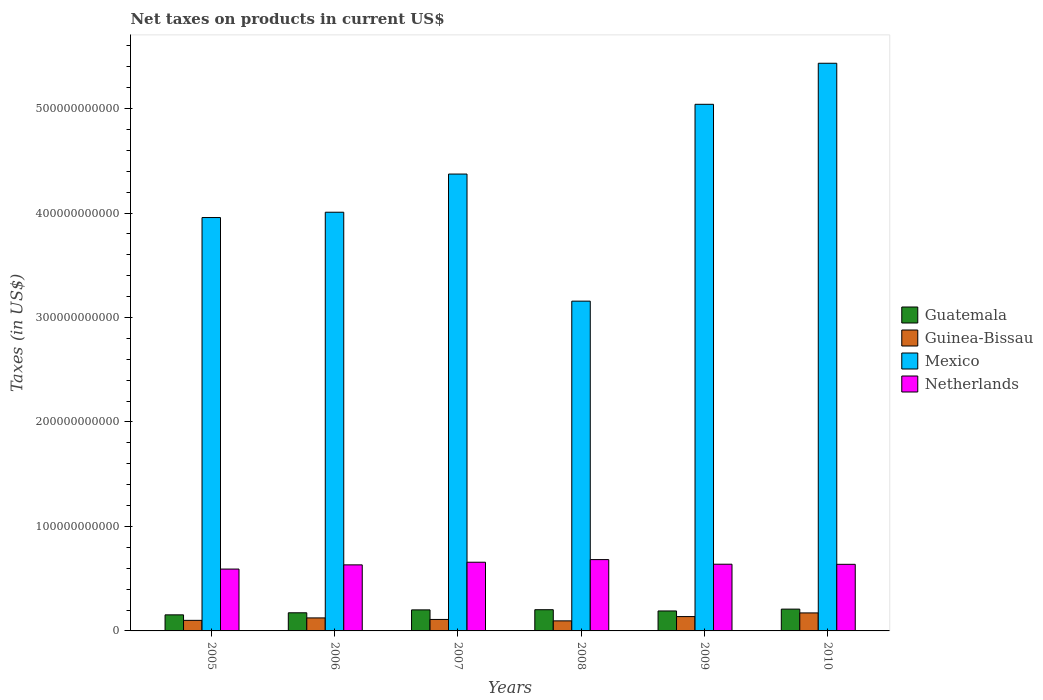How many groups of bars are there?
Give a very brief answer. 6. Are the number of bars per tick equal to the number of legend labels?
Your response must be concise. Yes. Are the number of bars on each tick of the X-axis equal?
Offer a very short reply. Yes. What is the label of the 5th group of bars from the left?
Your answer should be very brief. 2009. What is the net taxes on products in Guinea-Bissau in 2008?
Give a very brief answer. 9.62e+09. Across all years, what is the maximum net taxes on products in Guatemala?
Keep it short and to the point. 2.09e+1. Across all years, what is the minimum net taxes on products in Guinea-Bissau?
Your response must be concise. 9.62e+09. What is the total net taxes on products in Guinea-Bissau in the graph?
Give a very brief answer. 7.41e+1. What is the difference between the net taxes on products in Guatemala in 2006 and that in 2007?
Your response must be concise. -2.77e+09. What is the difference between the net taxes on products in Mexico in 2010 and the net taxes on products in Netherlands in 2009?
Give a very brief answer. 4.80e+11. What is the average net taxes on products in Guatemala per year?
Provide a short and direct response. 1.89e+1. In the year 2009, what is the difference between the net taxes on products in Guinea-Bissau and net taxes on products in Netherlands?
Your response must be concise. -5.01e+1. What is the ratio of the net taxes on products in Guatemala in 2009 to that in 2010?
Ensure brevity in your answer.  0.92. Is the difference between the net taxes on products in Guinea-Bissau in 2005 and 2009 greater than the difference between the net taxes on products in Netherlands in 2005 and 2009?
Your response must be concise. Yes. What is the difference between the highest and the second highest net taxes on products in Guinea-Bissau?
Give a very brief answer. 3.51e+09. What is the difference between the highest and the lowest net taxes on products in Netherlands?
Offer a terse response. 9.07e+09. Is the sum of the net taxes on products in Mexico in 2005 and 2006 greater than the maximum net taxes on products in Guatemala across all years?
Ensure brevity in your answer.  Yes. Is it the case that in every year, the sum of the net taxes on products in Guatemala and net taxes on products in Guinea-Bissau is greater than the sum of net taxes on products in Mexico and net taxes on products in Netherlands?
Keep it short and to the point. No. What does the 1st bar from the left in 2008 represents?
Offer a very short reply. Guatemala. What does the 3rd bar from the right in 2006 represents?
Ensure brevity in your answer.  Guinea-Bissau. Is it the case that in every year, the sum of the net taxes on products in Guatemala and net taxes on products in Guinea-Bissau is greater than the net taxes on products in Netherlands?
Ensure brevity in your answer.  No. Are all the bars in the graph horizontal?
Offer a very short reply. No. How many years are there in the graph?
Give a very brief answer. 6. What is the difference between two consecutive major ticks on the Y-axis?
Your response must be concise. 1.00e+11. Does the graph contain any zero values?
Offer a terse response. No. How are the legend labels stacked?
Your answer should be very brief. Vertical. What is the title of the graph?
Offer a very short reply. Net taxes on products in current US$. What is the label or title of the Y-axis?
Provide a short and direct response. Taxes (in US$). What is the Taxes (in US$) in Guatemala in 2005?
Provide a succinct answer. 1.54e+1. What is the Taxes (in US$) in Guinea-Bissau in 2005?
Provide a short and direct response. 1.01e+1. What is the Taxes (in US$) in Mexico in 2005?
Give a very brief answer. 3.96e+11. What is the Taxes (in US$) of Netherlands in 2005?
Make the answer very short. 5.92e+1. What is the Taxes (in US$) of Guatemala in 2006?
Your answer should be compact. 1.74e+1. What is the Taxes (in US$) of Guinea-Bissau in 2006?
Provide a short and direct response. 1.25e+1. What is the Taxes (in US$) of Mexico in 2006?
Offer a very short reply. 4.01e+11. What is the Taxes (in US$) in Netherlands in 2006?
Your answer should be very brief. 6.32e+1. What is the Taxes (in US$) in Guatemala in 2007?
Make the answer very short. 2.01e+1. What is the Taxes (in US$) of Guinea-Bissau in 2007?
Ensure brevity in your answer.  1.10e+1. What is the Taxes (in US$) of Mexico in 2007?
Your answer should be compact. 4.37e+11. What is the Taxes (in US$) in Netherlands in 2007?
Make the answer very short. 6.58e+1. What is the Taxes (in US$) in Guatemala in 2008?
Your answer should be very brief. 2.03e+1. What is the Taxes (in US$) in Guinea-Bissau in 2008?
Your answer should be compact. 9.62e+09. What is the Taxes (in US$) of Mexico in 2008?
Make the answer very short. 3.16e+11. What is the Taxes (in US$) in Netherlands in 2008?
Ensure brevity in your answer.  6.83e+1. What is the Taxes (in US$) of Guatemala in 2009?
Your answer should be very brief. 1.91e+1. What is the Taxes (in US$) in Guinea-Bissau in 2009?
Ensure brevity in your answer.  1.37e+1. What is the Taxes (in US$) of Mexico in 2009?
Make the answer very short. 5.04e+11. What is the Taxes (in US$) of Netherlands in 2009?
Ensure brevity in your answer.  6.39e+1. What is the Taxes (in US$) in Guatemala in 2010?
Your answer should be compact. 2.09e+1. What is the Taxes (in US$) in Guinea-Bissau in 2010?
Offer a very short reply. 1.72e+1. What is the Taxes (in US$) in Mexico in 2010?
Your answer should be very brief. 5.43e+11. What is the Taxes (in US$) in Netherlands in 2010?
Give a very brief answer. 6.38e+1. Across all years, what is the maximum Taxes (in US$) in Guatemala?
Offer a terse response. 2.09e+1. Across all years, what is the maximum Taxes (in US$) of Guinea-Bissau?
Keep it short and to the point. 1.72e+1. Across all years, what is the maximum Taxes (in US$) of Mexico?
Your response must be concise. 5.43e+11. Across all years, what is the maximum Taxes (in US$) of Netherlands?
Keep it short and to the point. 6.83e+1. Across all years, what is the minimum Taxes (in US$) in Guatemala?
Give a very brief answer. 1.54e+1. Across all years, what is the minimum Taxes (in US$) of Guinea-Bissau?
Provide a succinct answer. 9.62e+09. Across all years, what is the minimum Taxes (in US$) in Mexico?
Ensure brevity in your answer.  3.16e+11. Across all years, what is the minimum Taxes (in US$) of Netherlands?
Keep it short and to the point. 5.92e+1. What is the total Taxes (in US$) in Guatemala in the graph?
Keep it short and to the point. 1.13e+11. What is the total Taxes (in US$) of Guinea-Bissau in the graph?
Provide a short and direct response. 7.41e+1. What is the total Taxes (in US$) in Mexico in the graph?
Offer a terse response. 2.60e+12. What is the total Taxes (in US$) in Netherlands in the graph?
Your response must be concise. 3.84e+11. What is the difference between the Taxes (in US$) in Guatemala in 2005 and that in 2006?
Your answer should be compact. -1.97e+09. What is the difference between the Taxes (in US$) of Guinea-Bissau in 2005 and that in 2006?
Your answer should be very brief. -2.34e+09. What is the difference between the Taxes (in US$) in Mexico in 2005 and that in 2006?
Provide a short and direct response. -5.09e+09. What is the difference between the Taxes (in US$) of Netherlands in 2005 and that in 2006?
Offer a terse response. -4.02e+09. What is the difference between the Taxes (in US$) of Guatemala in 2005 and that in 2007?
Offer a terse response. -4.75e+09. What is the difference between the Taxes (in US$) of Guinea-Bissau in 2005 and that in 2007?
Provide a succinct answer. -8.67e+08. What is the difference between the Taxes (in US$) in Mexico in 2005 and that in 2007?
Ensure brevity in your answer.  -4.16e+1. What is the difference between the Taxes (in US$) of Netherlands in 2005 and that in 2007?
Provide a succinct answer. -6.56e+09. What is the difference between the Taxes (in US$) of Guatemala in 2005 and that in 2008?
Your answer should be very brief. -4.92e+09. What is the difference between the Taxes (in US$) in Guinea-Bissau in 2005 and that in 2008?
Keep it short and to the point. 4.96e+08. What is the difference between the Taxes (in US$) in Mexico in 2005 and that in 2008?
Ensure brevity in your answer.  8.00e+1. What is the difference between the Taxes (in US$) in Netherlands in 2005 and that in 2008?
Keep it short and to the point. -9.07e+09. What is the difference between the Taxes (in US$) of Guatemala in 2005 and that in 2009?
Your response must be concise. -3.72e+09. What is the difference between the Taxes (in US$) of Guinea-Bissau in 2005 and that in 2009?
Ensure brevity in your answer.  -3.60e+09. What is the difference between the Taxes (in US$) in Mexico in 2005 and that in 2009?
Give a very brief answer. -1.08e+11. What is the difference between the Taxes (in US$) in Netherlands in 2005 and that in 2009?
Your answer should be very brief. -4.64e+09. What is the difference between the Taxes (in US$) in Guatemala in 2005 and that in 2010?
Make the answer very short. -5.48e+09. What is the difference between the Taxes (in US$) of Guinea-Bissau in 2005 and that in 2010?
Your response must be concise. -7.11e+09. What is the difference between the Taxes (in US$) of Mexico in 2005 and that in 2010?
Make the answer very short. -1.48e+11. What is the difference between the Taxes (in US$) in Netherlands in 2005 and that in 2010?
Your answer should be compact. -4.55e+09. What is the difference between the Taxes (in US$) of Guatemala in 2006 and that in 2007?
Keep it short and to the point. -2.77e+09. What is the difference between the Taxes (in US$) of Guinea-Bissau in 2006 and that in 2007?
Ensure brevity in your answer.  1.47e+09. What is the difference between the Taxes (in US$) in Mexico in 2006 and that in 2007?
Your answer should be very brief. -3.65e+1. What is the difference between the Taxes (in US$) in Netherlands in 2006 and that in 2007?
Keep it short and to the point. -2.54e+09. What is the difference between the Taxes (in US$) in Guatemala in 2006 and that in 2008?
Your response must be concise. -2.95e+09. What is the difference between the Taxes (in US$) in Guinea-Bissau in 2006 and that in 2008?
Keep it short and to the point. 2.83e+09. What is the difference between the Taxes (in US$) of Mexico in 2006 and that in 2008?
Make the answer very short. 8.51e+1. What is the difference between the Taxes (in US$) of Netherlands in 2006 and that in 2008?
Offer a very short reply. -5.05e+09. What is the difference between the Taxes (in US$) of Guatemala in 2006 and that in 2009?
Make the answer very short. -1.74e+09. What is the difference between the Taxes (in US$) of Guinea-Bissau in 2006 and that in 2009?
Make the answer very short. -1.27e+09. What is the difference between the Taxes (in US$) in Mexico in 2006 and that in 2009?
Make the answer very short. -1.03e+11. What is the difference between the Taxes (in US$) in Netherlands in 2006 and that in 2009?
Ensure brevity in your answer.  -6.25e+08. What is the difference between the Taxes (in US$) of Guatemala in 2006 and that in 2010?
Provide a succinct answer. -3.51e+09. What is the difference between the Taxes (in US$) in Guinea-Bissau in 2006 and that in 2010?
Provide a succinct answer. -4.78e+09. What is the difference between the Taxes (in US$) in Mexico in 2006 and that in 2010?
Your answer should be compact. -1.43e+11. What is the difference between the Taxes (in US$) in Netherlands in 2006 and that in 2010?
Ensure brevity in your answer.  -5.29e+08. What is the difference between the Taxes (in US$) in Guatemala in 2007 and that in 2008?
Ensure brevity in your answer.  -1.72e+08. What is the difference between the Taxes (in US$) of Guinea-Bissau in 2007 and that in 2008?
Your answer should be very brief. 1.36e+09. What is the difference between the Taxes (in US$) of Mexico in 2007 and that in 2008?
Ensure brevity in your answer.  1.22e+11. What is the difference between the Taxes (in US$) of Netherlands in 2007 and that in 2008?
Keep it short and to the point. -2.51e+09. What is the difference between the Taxes (in US$) of Guatemala in 2007 and that in 2009?
Give a very brief answer. 1.03e+09. What is the difference between the Taxes (in US$) in Guinea-Bissau in 2007 and that in 2009?
Make the answer very short. -2.74e+09. What is the difference between the Taxes (in US$) of Mexico in 2007 and that in 2009?
Ensure brevity in your answer.  -6.68e+1. What is the difference between the Taxes (in US$) of Netherlands in 2007 and that in 2009?
Provide a succinct answer. 1.91e+09. What is the difference between the Taxes (in US$) in Guatemala in 2007 and that in 2010?
Provide a succinct answer. -7.35e+08. What is the difference between the Taxes (in US$) in Guinea-Bissau in 2007 and that in 2010?
Keep it short and to the point. -6.25e+09. What is the difference between the Taxes (in US$) in Mexico in 2007 and that in 2010?
Make the answer very short. -1.06e+11. What is the difference between the Taxes (in US$) in Netherlands in 2007 and that in 2010?
Your answer should be compact. 2.01e+09. What is the difference between the Taxes (in US$) of Guatemala in 2008 and that in 2009?
Provide a succinct answer. 1.20e+09. What is the difference between the Taxes (in US$) of Guinea-Bissau in 2008 and that in 2009?
Provide a short and direct response. -4.10e+09. What is the difference between the Taxes (in US$) in Mexico in 2008 and that in 2009?
Make the answer very short. -1.88e+11. What is the difference between the Taxes (in US$) of Netherlands in 2008 and that in 2009?
Ensure brevity in your answer.  4.42e+09. What is the difference between the Taxes (in US$) in Guatemala in 2008 and that in 2010?
Your answer should be compact. -5.63e+08. What is the difference between the Taxes (in US$) of Guinea-Bissau in 2008 and that in 2010?
Make the answer very short. -7.61e+09. What is the difference between the Taxes (in US$) in Mexico in 2008 and that in 2010?
Your answer should be compact. -2.28e+11. What is the difference between the Taxes (in US$) of Netherlands in 2008 and that in 2010?
Make the answer very short. 4.52e+09. What is the difference between the Taxes (in US$) of Guatemala in 2009 and that in 2010?
Make the answer very short. -1.76e+09. What is the difference between the Taxes (in US$) of Guinea-Bissau in 2009 and that in 2010?
Your answer should be compact. -3.51e+09. What is the difference between the Taxes (in US$) in Mexico in 2009 and that in 2010?
Provide a short and direct response. -3.93e+1. What is the difference between the Taxes (in US$) of Netherlands in 2009 and that in 2010?
Offer a very short reply. 9.60e+07. What is the difference between the Taxes (in US$) in Guatemala in 2005 and the Taxes (in US$) in Guinea-Bissau in 2006?
Your answer should be compact. 2.93e+09. What is the difference between the Taxes (in US$) in Guatemala in 2005 and the Taxes (in US$) in Mexico in 2006?
Ensure brevity in your answer.  -3.85e+11. What is the difference between the Taxes (in US$) of Guatemala in 2005 and the Taxes (in US$) of Netherlands in 2006?
Make the answer very short. -4.78e+1. What is the difference between the Taxes (in US$) of Guinea-Bissau in 2005 and the Taxes (in US$) of Mexico in 2006?
Your answer should be compact. -3.91e+11. What is the difference between the Taxes (in US$) in Guinea-Bissau in 2005 and the Taxes (in US$) in Netherlands in 2006?
Offer a very short reply. -5.31e+1. What is the difference between the Taxes (in US$) of Mexico in 2005 and the Taxes (in US$) of Netherlands in 2006?
Your response must be concise. 3.32e+11. What is the difference between the Taxes (in US$) of Guatemala in 2005 and the Taxes (in US$) of Guinea-Bissau in 2007?
Your answer should be very brief. 4.40e+09. What is the difference between the Taxes (in US$) of Guatemala in 2005 and the Taxes (in US$) of Mexico in 2007?
Offer a terse response. -4.22e+11. What is the difference between the Taxes (in US$) of Guatemala in 2005 and the Taxes (in US$) of Netherlands in 2007?
Provide a short and direct response. -5.04e+1. What is the difference between the Taxes (in US$) of Guinea-Bissau in 2005 and the Taxes (in US$) of Mexico in 2007?
Offer a terse response. -4.27e+11. What is the difference between the Taxes (in US$) of Guinea-Bissau in 2005 and the Taxes (in US$) of Netherlands in 2007?
Your answer should be very brief. -5.56e+1. What is the difference between the Taxes (in US$) in Mexico in 2005 and the Taxes (in US$) in Netherlands in 2007?
Ensure brevity in your answer.  3.30e+11. What is the difference between the Taxes (in US$) in Guatemala in 2005 and the Taxes (in US$) in Guinea-Bissau in 2008?
Ensure brevity in your answer.  5.77e+09. What is the difference between the Taxes (in US$) of Guatemala in 2005 and the Taxes (in US$) of Mexico in 2008?
Offer a very short reply. -3.00e+11. What is the difference between the Taxes (in US$) in Guatemala in 2005 and the Taxes (in US$) in Netherlands in 2008?
Your answer should be very brief. -5.29e+1. What is the difference between the Taxes (in US$) in Guinea-Bissau in 2005 and the Taxes (in US$) in Mexico in 2008?
Provide a succinct answer. -3.06e+11. What is the difference between the Taxes (in US$) of Guinea-Bissau in 2005 and the Taxes (in US$) of Netherlands in 2008?
Offer a terse response. -5.82e+1. What is the difference between the Taxes (in US$) of Mexico in 2005 and the Taxes (in US$) of Netherlands in 2008?
Offer a terse response. 3.27e+11. What is the difference between the Taxes (in US$) in Guatemala in 2005 and the Taxes (in US$) in Guinea-Bissau in 2009?
Your answer should be compact. 1.66e+09. What is the difference between the Taxes (in US$) of Guatemala in 2005 and the Taxes (in US$) of Mexico in 2009?
Your response must be concise. -4.89e+11. What is the difference between the Taxes (in US$) in Guatemala in 2005 and the Taxes (in US$) in Netherlands in 2009?
Keep it short and to the point. -4.85e+1. What is the difference between the Taxes (in US$) of Guinea-Bissau in 2005 and the Taxes (in US$) of Mexico in 2009?
Provide a succinct answer. -4.94e+11. What is the difference between the Taxes (in US$) in Guinea-Bissau in 2005 and the Taxes (in US$) in Netherlands in 2009?
Make the answer very short. -5.37e+1. What is the difference between the Taxes (in US$) in Mexico in 2005 and the Taxes (in US$) in Netherlands in 2009?
Your answer should be very brief. 3.32e+11. What is the difference between the Taxes (in US$) in Guatemala in 2005 and the Taxes (in US$) in Guinea-Bissau in 2010?
Offer a very short reply. -1.84e+09. What is the difference between the Taxes (in US$) of Guatemala in 2005 and the Taxes (in US$) of Mexico in 2010?
Provide a short and direct response. -5.28e+11. What is the difference between the Taxes (in US$) of Guatemala in 2005 and the Taxes (in US$) of Netherlands in 2010?
Your answer should be compact. -4.84e+1. What is the difference between the Taxes (in US$) of Guinea-Bissau in 2005 and the Taxes (in US$) of Mexico in 2010?
Make the answer very short. -5.33e+11. What is the difference between the Taxes (in US$) of Guinea-Bissau in 2005 and the Taxes (in US$) of Netherlands in 2010?
Your response must be concise. -5.36e+1. What is the difference between the Taxes (in US$) of Mexico in 2005 and the Taxes (in US$) of Netherlands in 2010?
Ensure brevity in your answer.  3.32e+11. What is the difference between the Taxes (in US$) of Guatemala in 2006 and the Taxes (in US$) of Guinea-Bissau in 2007?
Keep it short and to the point. 6.38e+09. What is the difference between the Taxes (in US$) in Guatemala in 2006 and the Taxes (in US$) in Mexico in 2007?
Give a very brief answer. -4.20e+11. What is the difference between the Taxes (in US$) of Guatemala in 2006 and the Taxes (in US$) of Netherlands in 2007?
Give a very brief answer. -4.84e+1. What is the difference between the Taxes (in US$) in Guinea-Bissau in 2006 and the Taxes (in US$) in Mexico in 2007?
Ensure brevity in your answer.  -4.25e+11. What is the difference between the Taxes (in US$) in Guinea-Bissau in 2006 and the Taxes (in US$) in Netherlands in 2007?
Provide a short and direct response. -5.33e+1. What is the difference between the Taxes (in US$) in Mexico in 2006 and the Taxes (in US$) in Netherlands in 2007?
Provide a short and direct response. 3.35e+11. What is the difference between the Taxes (in US$) in Guatemala in 2006 and the Taxes (in US$) in Guinea-Bissau in 2008?
Give a very brief answer. 7.74e+09. What is the difference between the Taxes (in US$) in Guatemala in 2006 and the Taxes (in US$) in Mexico in 2008?
Offer a very short reply. -2.98e+11. What is the difference between the Taxes (in US$) of Guatemala in 2006 and the Taxes (in US$) of Netherlands in 2008?
Give a very brief answer. -5.09e+1. What is the difference between the Taxes (in US$) of Guinea-Bissau in 2006 and the Taxes (in US$) of Mexico in 2008?
Your response must be concise. -3.03e+11. What is the difference between the Taxes (in US$) of Guinea-Bissau in 2006 and the Taxes (in US$) of Netherlands in 2008?
Provide a short and direct response. -5.58e+1. What is the difference between the Taxes (in US$) in Mexico in 2006 and the Taxes (in US$) in Netherlands in 2008?
Your answer should be compact. 3.33e+11. What is the difference between the Taxes (in US$) of Guatemala in 2006 and the Taxes (in US$) of Guinea-Bissau in 2009?
Give a very brief answer. 3.64e+09. What is the difference between the Taxes (in US$) in Guatemala in 2006 and the Taxes (in US$) in Mexico in 2009?
Offer a terse response. -4.87e+11. What is the difference between the Taxes (in US$) of Guatemala in 2006 and the Taxes (in US$) of Netherlands in 2009?
Your response must be concise. -4.65e+1. What is the difference between the Taxes (in US$) of Guinea-Bissau in 2006 and the Taxes (in US$) of Mexico in 2009?
Your answer should be compact. -4.92e+11. What is the difference between the Taxes (in US$) of Guinea-Bissau in 2006 and the Taxes (in US$) of Netherlands in 2009?
Ensure brevity in your answer.  -5.14e+1. What is the difference between the Taxes (in US$) in Mexico in 2006 and the Taxes (in US$) in Netherlands in 2009?
Keep it short and to the point. 3.37e+11. What is the difference between the Taxes (in US$) in Guatemala in 2006 and the Taxes (in US$) in Guinea-Bissau in 2010?
Keep it short and to the point. 1.31e+08. What is the difference between the Taxes (in US$) of Guatemala in 2006 and the Taxes (in US$) of Mexico in 2010?
Ensure brevity in your answer.  -5.26e+11. What is the difference between the Taxes (in US$) of Guatemala in 2006 and the Taxes (in US$) of Netherlands in 2010?
Your answer should be very brief. -4.64e+1. What is the difference between the Taxes (in US$) of Guinea-Bissau in 2006 and the Taxes (in US$) of Mexico in 2010?
Provide a short and direct response. -5.31e+11. What is the difference between the Taxes (in US$) of Guinea-Bissau in 2006 and the Taxes (in US$) of Netherlands in 2010?
Your answer should be very brief. -5.13e+1. What is the difference between the Taxes (in US$) in Mexico in 2006 and the Taxes (in US$) in Netherlands in 2010?
Provide a short and direct response. 3.37e+11. What is the difference between the Taxes (in US$) of Guatemala in 2007 and the Taxes (in US$) of Guinea-Bissau in 2008?
Provide a succinct answer. 1.05e+1. What is the difference between the Taxes (in US$) in Guatemala in 2007 and the Taxes (in US$) in Mexico in 2008?
Offer a very short reply. -2.96e+11. What is the difference between the Taxes (in US$) in Guatemala in 2007 and the Taxes (in US$) in Netherlands in 2008?
Ensure brevity in your answer.  -4.81e+1. What is the difference between the Taxes (in US$) of Guinea-Bissau in 2007 and the Taxes (in US$) of Mexico in 2008?
Provide a short and direct response. -3.05e+11. What is the difference between the Taxes (in US$) in Guinea-Bissau in 2007 and the Taxes (in US$) in Netherlands in 2008?
Your answer should be very brief. -5.73e+1. What is the difference between the Taxes (in US$) of Mexico in 2007 and the Taxes (in US$) of Netherlands in 2008?
Your answer should be very brief. 3.69e+11. What is the difference between the Taxes (in US$) of Guatemala in 2007 and the Taxes (in US$) of Guinea-Bissau in 2009?
Give a very brief answer. 6.41e+09. What is the difference between the Taxes (in US$) of Guatemala in 2007 and the Taxes (in US$) of Mexico in 2009?
Provide a short and direct response. -4.84e+11. What is the difference between the Taxes (in US$) in Guatemala in 2007 and the Taxes (in US$) in Netherlands in 2009?
Keep it short and to the point. -4.37e+1. What is the difference between the Taxes (in US$) in Guinea-Bissau in 2007 and the Taxes (in US$) in Mexico in 2009?
Provide a short and direct response. -4.93e+11. What is the difference between the Taxes (in US$) in Guinea-Bissau in 2007 and the Taxes (in US$) in Netherlands in 2009?
Keep it short and to the point. -5.29e+1. What is the difference between the Taxes (in US$) in Mexico in 2007 and the Taxes (in US$) in Netherlands in 2009?
Ensure brevity in your answer.  3.73e+11. What is the difference between the Taxes (in US$) of Guatemala in 2007 and the Taxes (in US$) of Guinea-Bissau in 2010?
Ensure brevity in your answer.  2.90e+09. What is the difference between the Taxes (in US$) of Guatemala in 2007 and the Taxes (in US$) of Mexico in 2010?
Offer a terse response. -5.23e+11. What is the difference between the Taxes (in US$) of Guatemala in 2007 and the Taxes (in US$) of Netherlands in 2010?
Offer a terse response. -4.36e+1. What is the difference between the Taxes (in US$) in Guinea-Bissau in 2007 and the Taxes (in US$) in Mexico in 2010?
Provide a short and direct response. -5.32e+11. What is the difference between the Taxes (in US$) in Guinea-Bissau in 2007 and the Taxes (in US$) in Netherlands in 2010?
Provide a succinct answer. -5.28e+1. What is the difference between the Taxes (in US$) of Mexico in 2007 and the Taxes (in US$) of Netherlands in 2010?
Offer a terse response. 3.74e+11. What is the difference between the Taxes (in US$) of Guatemala in 2008 and the Taxes (in US$) of Guinea-Bissau in 2009?
Your answer should be compact. 6.58e+09. What is the difference between the Taxes (in US$) in Guatemala in 2008 and the Taxes (in US$) in Mexico in 2009?
Keep it short and to the point. -4.84e+11. What is the difference between the Taxes (in US$) in Guatemala in 2008 and the Taxes (in US$) in Netherlands in 2009?
Your response must be concise. -4.35e+1. What is the difference between the Taxes (in US$) of Guinea-Bissau in 2008 and the Taxes (in US$) of Mexico in 2009?
Provide a succinct answer. -4.94e+11. What is the difference between the Taxes (in US$) of Guinea-Bissau in 2008 and the Taxes (in US$) of Netherlands in 2009?
Your response must be concise. -5.42e+1. What is the difference between the Taxes (in US$) of Mexico in 2008 and the Taxes (in US$) of Netherlands in 2009?
Your answer should be very brief. 2.52e+11. What is the difference between the Taxes (in US$) in Guatemala in 2008 and the Taxes (in US$) in Guinea-Bissau in 2010?
Your response must be concise. 3.08e+09. What is the difference between the Taxes (in US$) of Guatemala in 2008 and the Taxes (in US$) of Mexico in 2010?
Keep it short and to the point. -5.23e+11. What is the difference between the Taxes (in US$) of Guatemala in 2008 and the Taxes (in US$) of Netherlands in 2010?
Give a very brief answer. -4.34e+1. What is the difference between the Taxes (in US$) in Guinea-Bissau in 2008 and the Taxes (in US$) in Mexico in 2010?
Offer a terse response. -5.34e+11. What is the difference between the Taxes (in US$) of Guinea-Bissau in 2008 and the Taxes (in US$) of Netherlands in 2010?
Ensure brevity in your answer.  -5.41e+1. What is the difference between the Taxes (in US$) of Mexico in 2008 and the Taxes (in US$) of Netherlands in 2010?
Your response must be concise. 2.52e+11. What is the difference between the Taxes (in US$) of Guatemala in 2009 and the Taxes (in US$) of Guinea-Bissau in 2010?
Provide a succinct answer. 1.87e+09. What is the difference between the Taxes (in US$) in Guatemala in 2009 and the Taxes (in US$) in Mexico in 2010?
Ensure brevity in your answer.  -5.24e+11. What is the difference between the Taxes (in US$) of Guatemala in 2009 and the Taxes (in US$) of Netherlands in 2010?
Make the answer very short. -4.46e+1. What is the difference between the Taxes (in US$) in Guinea-Bissau in 2009 and the Taxes (in US$) in Mexico in 2010?
Offer a terse response. -5.30e+11. What is the difference between the Taxes (in US$) of Guinea-Bissau in 2009 and the Taxes (in US$) of Netherlands in 2010?
Give a very brief answer. -5.00e+1. What is the difference between the Taxes (in US$) in Mexico in 2009 and the Taxes (in US$) in Netherlands in 2010?
Offer a very short reply. 4.40e+11. What is the average Taxes (in US$) of Guatemala per year?
Provide a short and direct response. 1.89e+1. What is the average Taxes (in US$) of Guinea-Bissau per year?
Give a very brief answer. 1.24e+1. What is the average Taxes (in US$) of Mexico per year?
Offer a very short reply. 4.33e+11. What is the average Taxes (in US$) of Netherlands per year?
Give a very brief answer. 6.40e+1. In the year 2005, what is the difference between the Taxes (in US$) of Guatemala and Taxes (in US$) of Guinea-Bissau?
Make the answer very short. 5.27e+09. In the year 2005, what is the difference between the Taxes (in US$) in Guatemala and Taxes (in US$) in Mexico?
Make the answer very short. -3.80e+11. In the year 2005, what is the difference between the Taxes (in US$) in Guatemala and Taxes (in US$) in Netherlands?
Your answer should be very brief. -4.38e+1. In the year 2005, what is the difference between the Taxes (in US$) in Guinea-Bissau and Taxes (in US$) in Mexico?
Offer a very short reply. -3.86e+11. In the year 2005, what is the difference between the Taxes (in US$) in Guinea-Bissau and Taxes (in US$) in Netherlands?
Provide a succinct answer. -4.91e+1. In the year 2005, what is the difference between the Taxes (in US$) of Mexico and Taxes (in US$) of Netherlands?
Offer a very short reply. 3.36e+11. In the year 2006, what is the difference between the Taxes (in US$) of Guatemala and Taxes (in US$) of Guinea-Bissau?
Offer a terse response. 4.91e+09. In the year 2006, what is the difference between the Taxes (in US$) of Guatemala and Taxes (in US$) of Mexico?
Make the answer very short. -3.83e+11. In the year 2006, what is the difference between the Taxes (in US$) of Guatemala and Taxes (in US$) of Netherlands?
Ensure brevity in your answer.  -4.59e+1. In the year 2006, what is the difference between the Taxes (in US$) in Guinea-Bissau and Taxes (in US$) in Mexico?
Give a very brief answer. -3.88e+11. In the year 2006, what is the difference between the Taxes (in US$) in Guinea-Bissau and Taxes (in US$) in Netherlands?
Provide a succinct answer. -5.08e+1. In the year 2006, what is the difference between the Taxes (in US$) in Mexico and Taxes (in US$) in Netherlands?
Your response must be concise. 3.38e+11. In the year 2007, what is the difference between the Taxes (in US$) in Guatemala and Taxes (in US$) in Guinea-Bissau?
Your answer should be very brief. 9.15e+09. In the year 2007, what is the difference between the Taxes (in US$) of Guatemala and Taxes (in US$) of Mexico?
Offer a terse response. -4.17e+11. In the year 2007, what is the difference between the Taxes (in US$) in Guatemala and Taxes (in US$) in Netherlands?
Make the answer very short. -4.56e+1. In the year 2007, what is the difference between the Taxes (in US$) in Guinea-Bissau and Taxes (in US$) in Mexico?
Ensure brevity in your answer.  -4.26e+11. In the year 2007, what is the difference between the Taxes (in US$) of Guinea-Bissau and Taxes (in US$) of Netherlands?
Offer a terse response. -5.48e+1. In the year 2007, what is the difference between the Taxes (in US$) in Mexico and Taxes (in US$) in Netherlands?
Offer a very short reply. 3.72e+11. In the year 2008, what is the difference between the Taxes (in US$) in Guatemala and Taxes (in US$) in Guinea-Bissau?
Make the answer very short. 1.07e+1. In the year 2008, what is the difference between the Taxes (in US$) of Guatemala and Taxes (in US$) of Mexico?
Your answer should be compact. -2.95e+11. In the year 2008, what is the difference between the Taxes (in US$) of Guatemala and Taxes (in US$) of Netherlands?
Give a very brief answer. -4.80e+1. In the year 2008, what is the difference between the Taxes (in US$) of Guinea-Bissau and Taxes (in US$) of Mexico?
Provide a succinct answer. -3.06e+11. In the year 2008, what is the difference between the Taxes (in US$) of Guinea-Bissau and Taxes (in US$) of Netherlands?
Your answer should be very brief. -5.87e+1. In the year 2008, what is the difference between the Taxes (in US$) of Mexico and Taxes (in US$) of Netherlands?
Offer a terse response. 2.47e+11. In the year 2009, what is the difference between the Taxes (in US$) in Guatemala and Taxes (in US$) in Guinea-Bissau?
Give a very brief answer. 5.38e+09. In the year 2009, what is the difference between the Taxes (in US$) in Guatemala and Taxes (in US$) in Mexico?
Ensure brevity in your answer.  -4.85e+11. In the year 2009, what is the difference between the Taxes (in US$) of Guatemala and Taxes (in US$) of Netherlands?
Make the answer very short. -4.47e+1. In the year 2009, what is the difference between the Taxes (in US$) of Guinea-Bissau and Taxes (in US$) of Mexico?
Make the answer very short. -4.90e+11. In the year 2009, what is the difference between the Taxes (in US$) of Guinea-Bissau and Taxes (in US$) of Netherlands?
Provide a succinct answer. -5.01e+1. In the year 2009, what is the difference between the Taxes (in US$) in Mexico and Taxes (in US$) in Netherlands?
Keep it short and to the point. 4.40e+11. In the year 2010, what is the difference between the Taxes (in US$) of Guatemala and Taxes (in US$) of Guinea-Bissau?
Provide a short and direct response. 3.64e+09. In the year 2010, what is the difference between the Taxes (in US$) in Guatemala and Taxes (in US$) in Mexico?
Make the answer very short. -5.23e+11. In the year 2010, what is the difference between the Taxes (in US$) of Guatemala and Taxes (in US$) of Netherlands?
Offer a very short reply. -4.29e+1. In the year 2010, what is the difference between the Taxes (in US$) in Guinea-Bissau and Taxes (in US$) in Mexico?
Offer a terse response. -5.26e+11. In the year 2010, what is the difference between the Taxes (in US$) of Guinea-Bissau and Taxes (in US$) of Netherlands?
Offer a terse response. -4.65e+1. In the year 2010, what is the difference between the Taxes (in US$) of Mexico and Taxes (in US$) of Netherlands?
Provide a succinct answer. 4.80e+11. What is the ratio of the Taxes (in US$) in Guatemala in 2005 to that in 2006?
Your answer should be very brief. 0.89. What is the ratio of the Taxes (in US$) in Guinea-Bissau in 2005 to that in 2006?
Provide a short and direct response. 0.81. What is the ratio of the Taxes (in US$) of Mexico in 2005 to that in 2006?
Give a very brief answer. 0.99. What is the ratio of the Taxes (in US$) in Netherlands in 2005 to that in 2006?
Ensure brevity in your answer.  0.94. What is the ratio of the Taxes (in US$) in Guatemala in 2005 to that in 2007?
Provide a short and direct response. 0.76. What is the ratio of the Taxes (in US$) of Guinea-Bissau in 2005 to that in 2007?
Keep it short and to the point. 0.92. What is the ratio of the Taxes (in US$) in Mexico in 2005 to that in 2007?
Keep it short and to the point. 0.9. What is the ratio of the Taxes (in US$) in Netherlands in 2005 to that in 2007?
Give a very brief answer. 0.9. What is the ratio of the Taxes (in US$) in Guatemala in 2005 to that in 2008?
Make the answer very short. 0.76. What is the ratio of the Taxes (in US$) of Guinea-Bissau in 2005 to that in 2008?
Your answer should be very brief. 1.05. What is the ratio of the Taxes (in US$) in Mexico in 2005 to that in 2008?
Provide a succinct answer. 1.25. What is the ratio of the Taxes (in US$) in Netherlands in 2005 to that in 2008?
Offer a terse response. 0.87. What is the ratio of the Taxes (in US$) of Guatemala in 2005 to that in 2009?
Make the answer very short. 0.81. What is the ratio of the Taxes (in US$) of Guinea-Bissau in 2005 to that in 2009?
Provide a succinct answer. 0.74. What is the ratio of the Taxes (in US$) in Mexico in 2005 to that in 2009?
Give a very brief answer. 0.79. What is the ratio of the Taxes (in US$) in Netherlands in 2005 to that in 2009?
Your answer should be compact. 0.93. What is the ratio of the Taxes (in US$) in Guatemala in 2005 to that in 2010?
Your answer should be compact. 0.74. What is the ratio of the Taxes (in US$) of Guinea-Bissau in 2005 to that in 2010?
Give a very brief answer. 0.59. What is the ratio of the Taxes (in US$) in Mexico in 2005 to that in 2010?
Provide a succinct answer. 0.73. What is the ratio of the Taxes (in US$) in Netherlands in 2005 to that in 2010?
Your answer should be very brief. 0.93. What is the ratio of the Taxes (in US$) of Guatemala in 2006 to that in 2007?
Offer a very short reply. 0.86. What is the ratio of the Taxes (in US$) in Guinea-Bissau in 2006 to that in 2007?
Your answer should be compact. 1.13. What is the ratio of the Taxes (in US$) in Mexico in 2006 to that in 2007?
Provide a succinct answer. 0.92. What is the ratio of the Taxes (in US$) of Netherlands in 2006 to that in 2007?
Your answer should be compact. 0.96. What is the ratio of the Taxes (in US$) of Guatemala in 2006 to that in 2008?
Provide a succinct answer. 0.85. What is the ratio of the Taxes (in US$) of Guinea-Bissau in 2006 to that in 2008?
Your answer should be very brief. 1.29. What is the ratio of the Taxes (in US$) in Mexico in 2006 to that in 2008?
Your response must be concise. 1.27. What is the ratio of the Taxes (in US$) in Netherlands in 2006 to that in 2008?
Your answer should be very brief. 0.93. What is the ratio of the Taxes (in US$) in Guatemala in 2006 to that in 2009?
Your response must be concise. 0.91. What is the ratio of the Taxes (in US$) of Guinea-Bissau in 2006 to that in 2009?
Offer a very short reply. 0.91. What is the ratio of the Taxes (in US$) of Mexico in 2006 to that in 2009?
Make the answer very short. 0.8. What is the ratio of the Taxes (in US$) of Netherlands in 2006 to that in 2009?
Your answer should be compact. 0.99. What is the ratio of the Taxes (in US$) of Guatemala in 2006 to that in 2010?
Ensure brevity in your answer.  0.83. What is the ratio of the Taxes (in US$) in Guinea-Bissau in 2006 to that in 2010?
Offer a terse response. 0.72. What is the ratio of the Taxes (in US$) in Mexico in 2006 to that in 2010?
Make the answer very short. 0.74. What is the ratio of the Taxes (in US$) in Netherlands in 2006 to that in 2010?
Your answer should be compact. 0.99. What is the ratio of the Taxes (in US$) of Guatemala in 2007 to that in 2008?
Your answer should be compact. 0.99. What is the ratio of the Taxes (in US$) of Guinea-Bissau in 2007 to that in 2008?
Give a very brief answer. 1.14. What is the ratio of the Taxes (in US$) of Mexico in 2007 to that in 2008?
Your response must be concise. 1.39. What is the ratio of the Taxes (in US$) in Netherlands in 2007 to that in 2008?
Your answer should be very brief. 0.96. What is the ratio of the Taxes (in US$) of Guatemala in 2007 to that in 2009?
Make the answer very short. 1.05. What is the ratio of the Taxes (in US$) in Guinea-Bissau in 2007 to that in 2009?
Your answer should be very brief. 0.8. What is the ratio of the Taxes (in US$) of Mexico in 2007 to that in 2009?
Your answer should be very brief. 0.87. What is the ratio of the Taxes (in US$) of Netherlands in 2007 to that in 2009?
Offer a terse response. 1.03. What is the ratio of the Taxes (in US$) of Guatemala in 2007 to that in 2010?
Keep it short and to the point. 0.96. What is the ratio of the Taxes (in US$) in Guinea-Bissau in 2007 to that in 2010?
Keep it short and to the point. 0.64. What is the ratio of the Taxes (in US$) of Mexico in 2007 to that in 2010?
Give a very brief answer. 0.8. What is the ratio of the Taxes (in US$) in Netherlands in 2007 to that in 2010?
Offer a terse response. 1.03. What is the ratio of the Taxes (in US$) in Guatemala in 2008 to that in 2009?
Offer a terse response. 1.06. What is the ratio of the Taxes (in US$) in Guinea-Bissau in 2008 to that in 2009?
Ensure brevity in your answer.  0.7. What is the ratio of the Taxes (in US$) of Mexico in 2008 to that in 2009?
Your response must be concise. 0.63. What is the ratio of the Taxes (in US$) of Netherlands in 2008 to that in 2009?
Your response must be concise. 1.07. What is the ratio of the Taxes (in US$) in Guinea-Bissau in 2008 to that in 2010?
Your response must be concise. 0.56. What is the ratio of the Taxes (in US$) in Mexico in 2008 to that in 2010?
Your answer should be very brief. 0.58. What is the ratio of the Taxes (in US$) in Netherlands in 2008 to that in 2010?
Offer a terse response. 1.07. What is the ratio of the Taxes (in US$) in Guatemala in 2009 to that in 2010?
Keep it short and to the point. 0.92. What is the ratio of the Taxes (in US$) in Guinea-Bissau in 2009 to that in 2010?
Ensure brevity in your answer.  0.8. What is the ratio of the Taxes (in US$) in Mexico in 2009 to that in 2010?
Keep it short and to the point. 0.93. What is the ratio of the Taxes (in US$) in Netherlands in 2009 to that in 2010?
Your response must be concise. 1. What is the difference between the highest and the second highest Taxes (in US$) of Guatemala?
Offer a terse response. 5.63e+08. What is the difference between the highest and the second highest Taxes (in US$) of Guinea-Bissau?
Ensure brevity in your answer.  3.51e+09. What is the difference between the highest and the second highest Taxes (in US$) in Mexico?
Your answer should be very brief. 3.93e+1. What is the difference between the highest and the second highest Taxes (in US$) in Netherlands?
Provide a succinct answer. 2.51e+09. What is the difference between the highest and the lowest Taxes (in US$) in Guatemala?
Provide a short and direct response. 5.48e+09. What is the difference between the highest and the lowest Taxes (in US$) of Guinea-Bissau?
Make the answer very short. 7.61e+09. What is the difference between the highest and the lowest Taxes (in US$) of Mexico?
Provide a succinct answer. 2.28e+11. What is the difference between the highest and the lowest Taxes (in US$) of Netherlands?
Provide a succinct answer. 9.07e+09. 